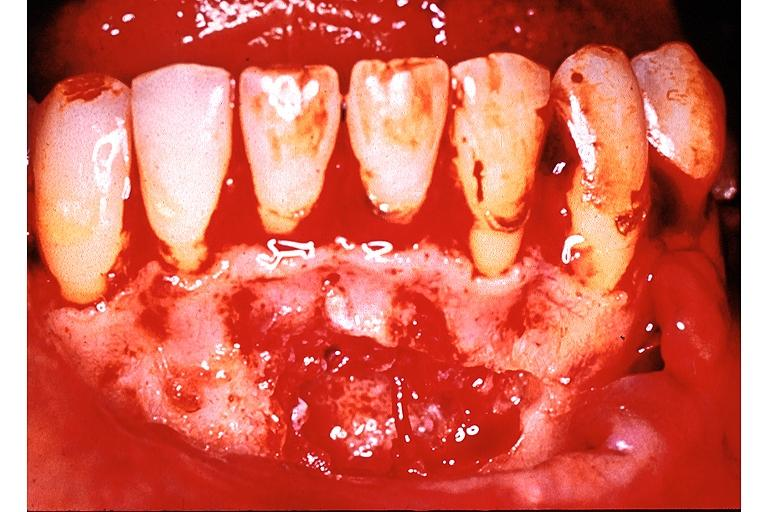s oral present?
Answer the question using a single word or phrase. Yes 